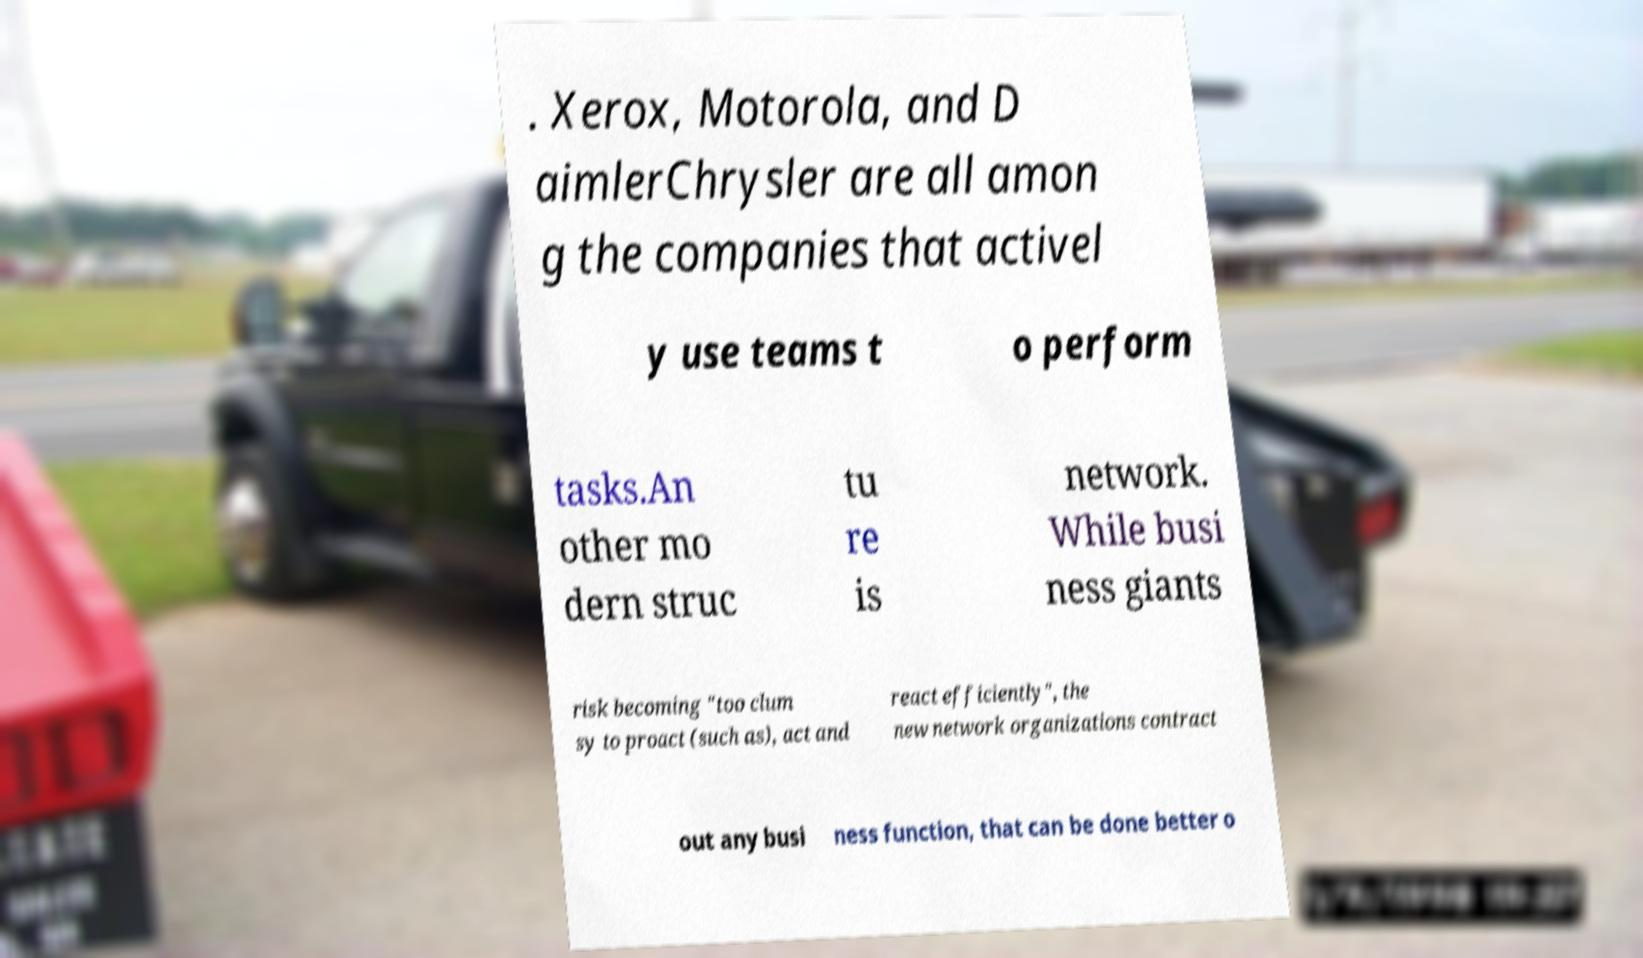For documentation purposes, I need the text within this image transcribed. Could you provide that? . Xerox, Motorola, and D aimlerChrysler are all amon g the companies that activel y use teams t o perform tasks.An other mo dern struc tu re is network. While busi ness giants risk becoming "too clum sy to proact (such as), act and react efficiently", the new network organizations contract out any busi ness function, that can be done better o 